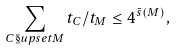Convert formula to latex. <formula><loc_0><loc_0><loc_500><loc_500>\sum _ { C \S u p s e t M } t _ { C } / t _ { M } \leq 4 ^ { \bar { s } ( M ) } ,</formula> 